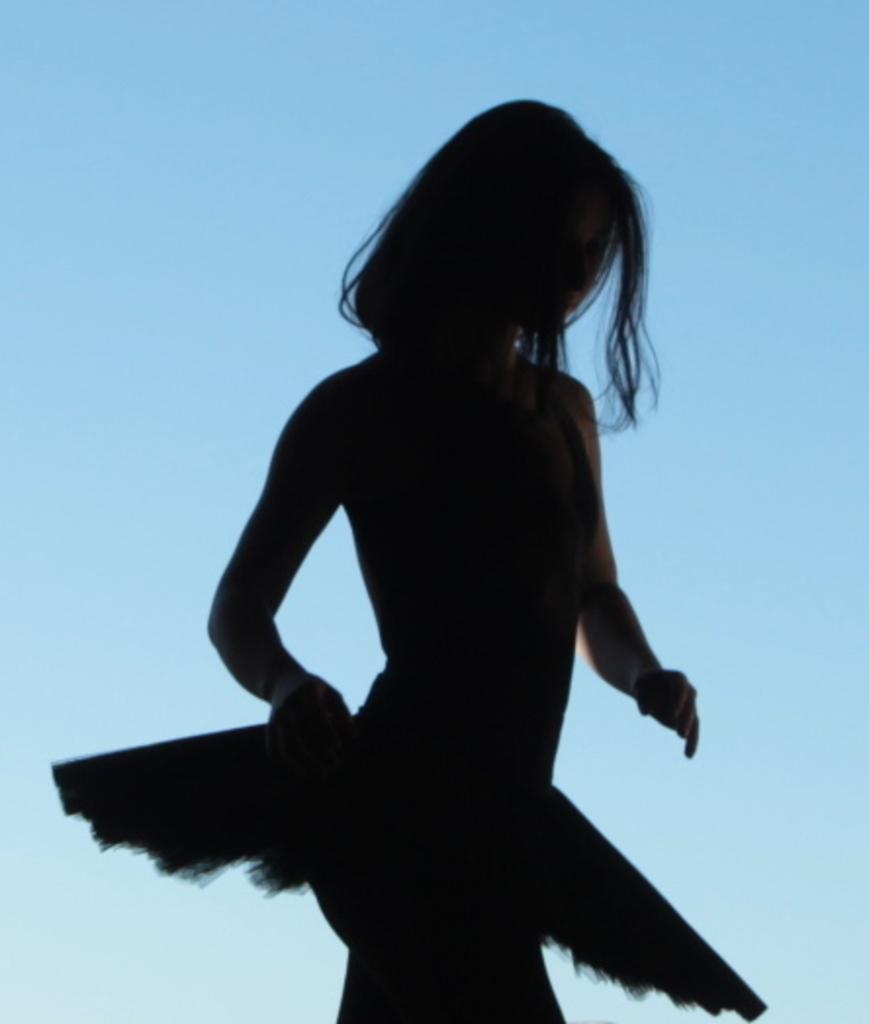Please provide a concise description of this image. In the center of the image , we can see a lady. 